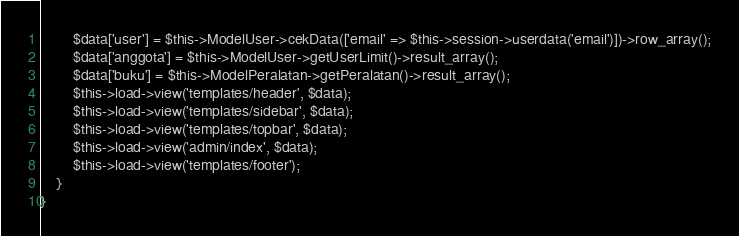Convert code to text. <code><loc_0><loc_0><loc_500><loc_500><_PHP_>        $data['user'] = $this->ModelUser->cekData(['email' => $this->session->userdata('email')])->row_array();
        $data['anggota'] = $this->ModelUser->getUserLimit()->result_array();
        $data['buku'] = $this->ModelPeralatan->getPeralatan()->result_array();
        $this->load->view('templates/header', $data);
        $this->load->view('templates/sidebar', $data);
        $this->load->view('templates/topbar', $data);
        $this->load->view('admin/index', $data);
        $this->load->view('templates/footer');
    }
}</code> 